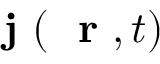<formula> <loc_0><loc_0><loc_500><loc_500>j ( r , t )</formula> 